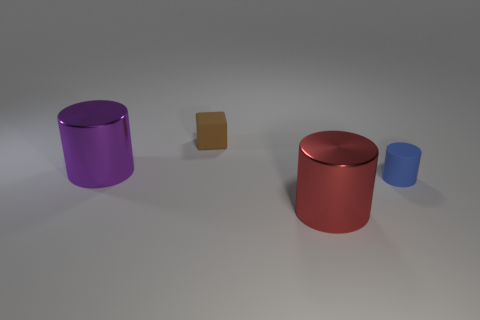Subtract all purple cylinders. How many cylinders are left? 2 Subtract all cylinders. How many objects are left? 1 Subtract 1 blocks. How many blocks are left? 0 Add 3 tiny yellow cubes. How many objects exist? 7 Subtract all red cylinders. How many cylinders are left? 2 Subtract 0 yellow cylinders. How many objects are left? 4 Subtract all green cylinders. Subtract all red spheres. How many cylinders are left? 3 Subtract all blue blocks. How many red cylinders are left? 1 Subtract all brown blocks. Subtract all blue cylinders. How many objects are left? 2 Add 2 brown rubber blocks. How many brown rubber blocks are left? 3 